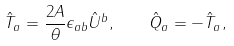Convert formula to latex. <formula><loc_0><loc_0><loc_500><loc_500>\hat { T } _ { a } = \frac { 2 A } { \theta } \epsilon _ { a b } \hat { U } ^ { b } , \quad \hat { Q } _ { a } = - \hat { T } _ { a } ,</formula> 